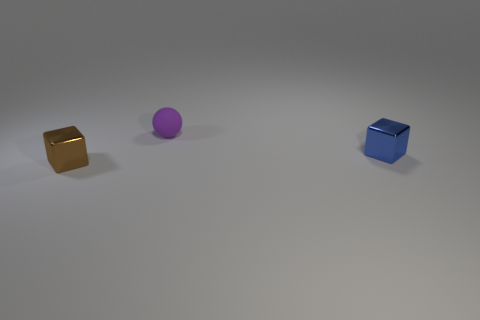Subtract all balls. How many objects are left? 2 Subtract 1 cubes. How many cubes are left? 1 Subtract all red spheres. Subtract all cyan cubes. How many spheres are left? 1 Subtract all purple cylinders. How many green blocks are left? 0 Subtract all large blue blocks. Subtract all tiny purple rubber spheres. How many objects are left? 2 Add 1 tiny blue cubes. How many tiny blue cubes are left? 2 Add 3 large red rubber spheres. How many large red rubber spheres exist? 3 Add 2 big rubber things. How many objects exist? 5 Subtract all blue blocks. How many blocks are left? 1 Subtract 0 cyan spheres. How many objects are left? 3 